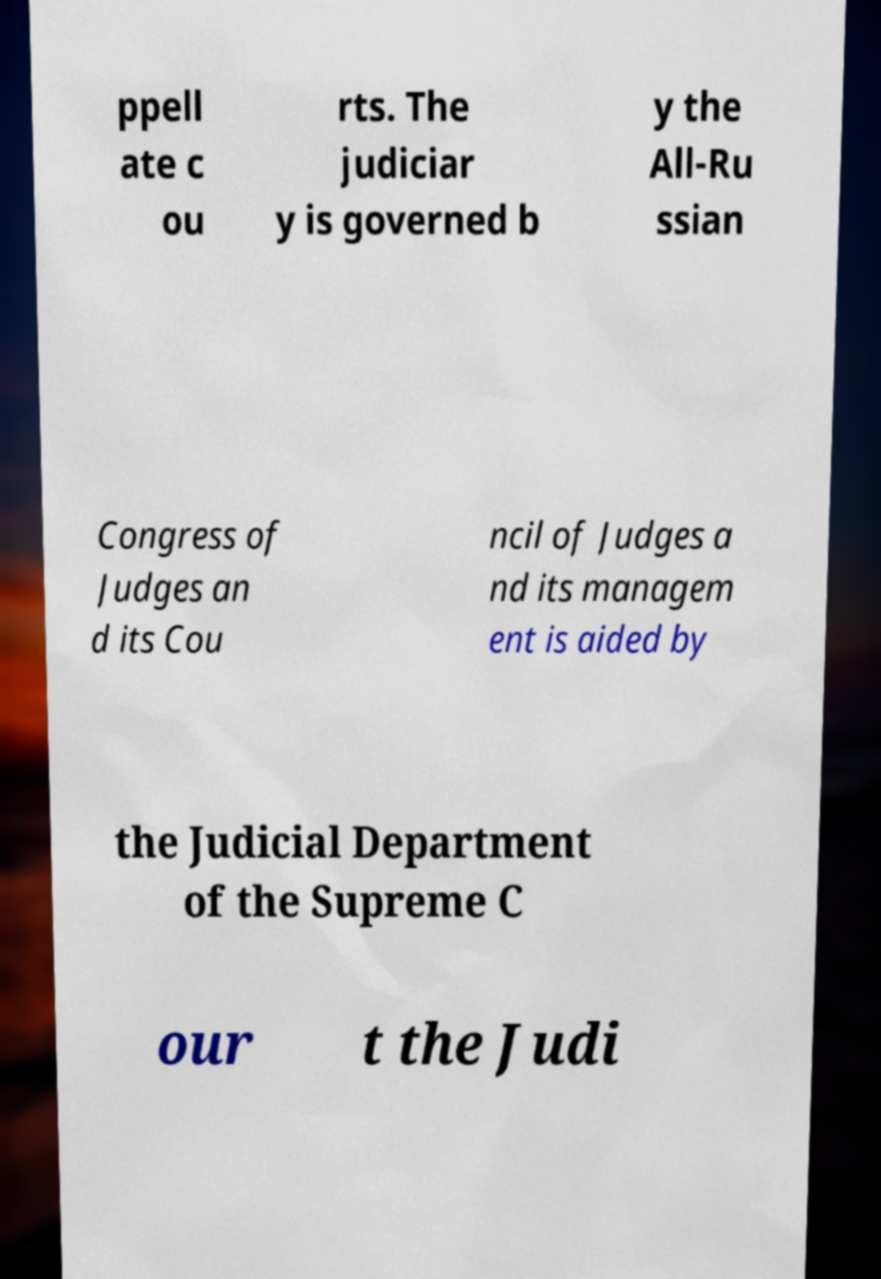For documentation purposes, I need the text within this image transcribed. Could you provide that? ppell ate c ou rts. The judiciar y is governed b y the All-Ru ssian Congress of Judges an d its Cou ncil of Judges a nd its managem ent is aided by the Judicial Department of the Supreme C our t the Judi 